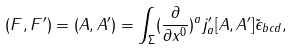Convert formula to latex. <formula><loc_0><loc_0><loc_500><loc_500>( F , F ^ { \prime } ) = ( A , A ^ { \prime } ) = \int _ { \Sigma } ( \frac { \partial } { \partial x ^ { 0 } } ) ^ { a } j ^ { \prime } _ { a } [ A , A ^ { \prime } ] \tilde { \epsilon } _ { b c d } ,</formula> 